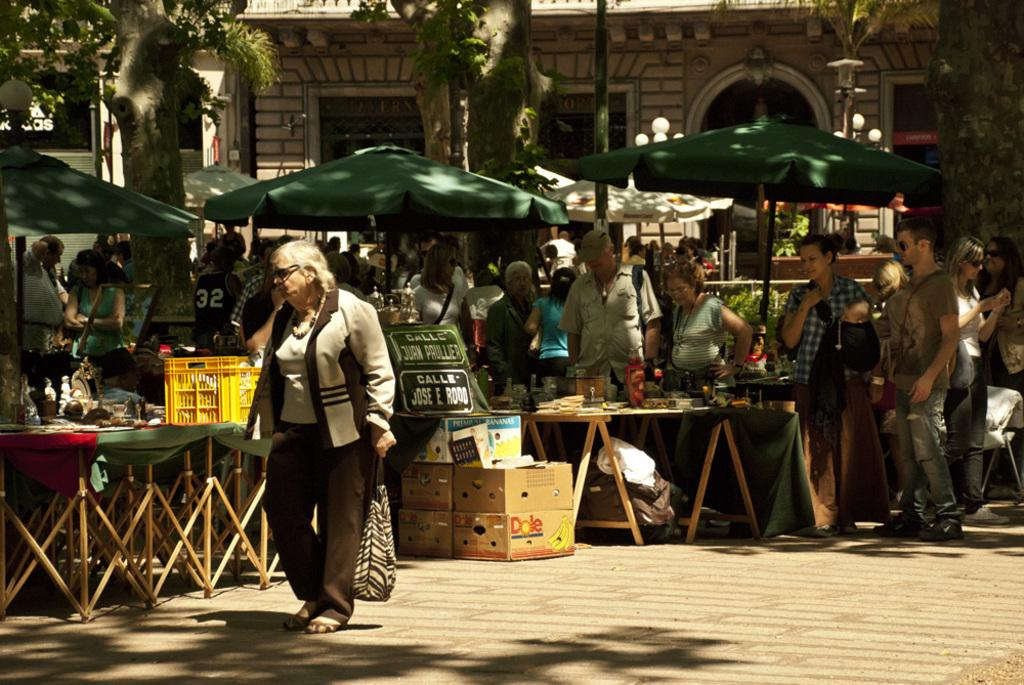<image>
Describe the image concisely. license plates outside customized with the words 'calle jose e rood' on them 